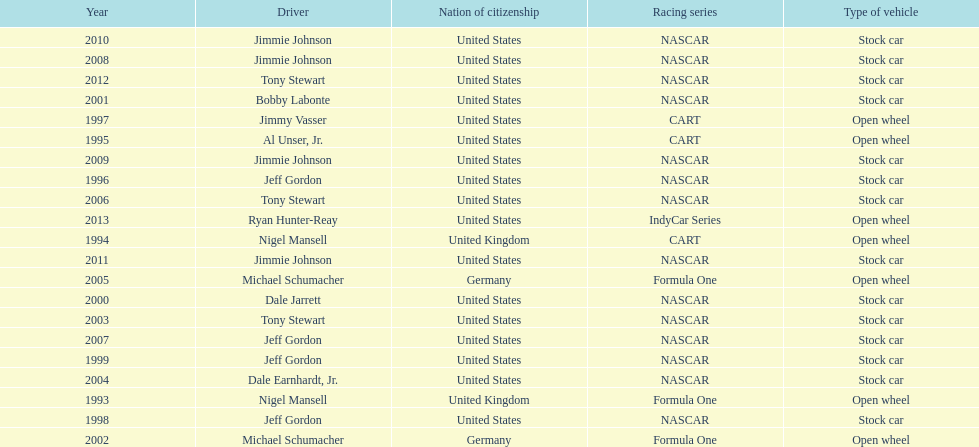Which driver won espy awards 11 years apart from each other? Jeff Gordon. 